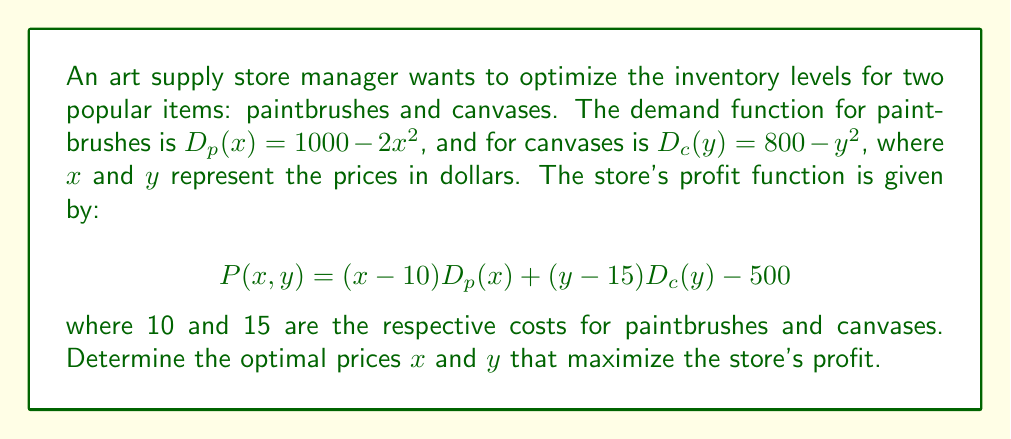Can you solve this math problem? To find the optimal prices, we need to maximize the profit function $P(x,y)$. This is a nonlinear optimization problem that can be solved using partial derivatives.

Step 1: Express the profit function in terms of $x$ and $y$.
$$P(x,y) = (x-10)(1000-2x^2) + (y-15)(800-y^2) - 500$$
$$P(x,y) = (1000x - 10000 - 2x^3 + 20x^2) + (800y - 12000 - y^3 + 15y^2) - 500$$
$$P(x,y) = -2x^3 + 20x^2 + 1000x - y^3 + 15y^2 + 800y - 22500$$

Step 2: Find the partial derivatives of $P$ with respect to $x$ and $y$.
$$\frac{\partial P}{\partial x} = -6x^2 + 40x + 1000$$
$$\frac{\partial P}{\partial y} = -3y^2 + 30y + 800$$

Step 3: Set both partial derivatives to zero to find the critical points.
$$-6x^2 + 40x + 1000 = 0$$
$$-3y^2 + 30y + 800 = 0$$

Step 4: Solve these equations.
For $x$: $-6x^2 + 40x + 1000 = 0$
$x^2 - \frac{20}{3}x - \frac{500}{3} = 0$
Using the quadratic formula, we get:
$x = \frac{20 \pm \sqrt{400 + 4000}}{12} = \frac{20 \pm \sqrt{4400}}{12}$
$x \approx 15.92$ or $x \approx -10.59$ (discard negative solution)

For $y$: $-3y^2 + 30y + 800 = 0$
$y^2 - 10y - \frac{800}{3} = 0$
Using the quadratic formula, we get:
$y = \frac{10 \pm \sqrt{100 + 3200/3}}{2} = \frac{10 \pm \sqrt{1166.67}}{2}$
$y \approx 20.08$ or $y \approx -10.08$ (discard negative solution)

Step 5: Verify that this critical point is indeed a maximum by checking the second partial derivatives (omitted for brevity).

Therefore, the optimal prices are approximately $x = 15.92$ for paintbrushes and $y = 20.08$ for canvases.
Answer: $x \approx 15.92, y \approx 20.08$ 